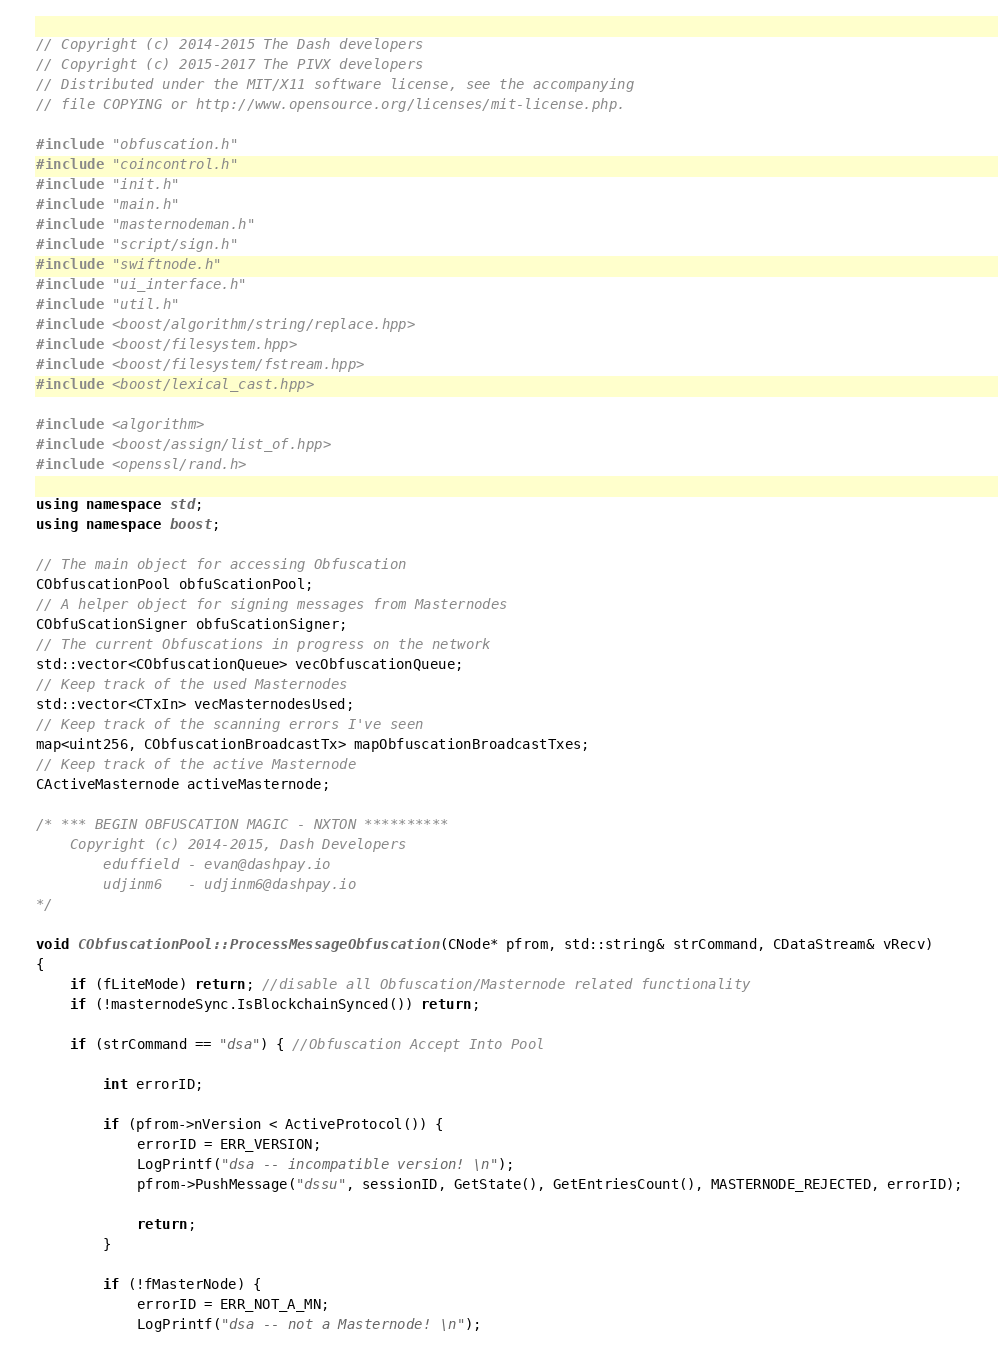Convert code to text. <code><loc_0><loc_0><loc_500><loc_500><_C++_>// Copyright (c) 2014-2015 The Dash developers
// Copyright (c) 2015-2017 The PIVX developers
// Distributed under the MIT/X11 software license, see the accompanying
// file COPYING or http://www.opensource.org/licenses/mit-license.php.

#include "obfuscation.h"
#include "coincontrol.h"
#include "init.h"
#include "main.h"
#include "masternodeman.h"
#include "script/sign.h"
#include "swiftnode.h"
#include "ui_interface.h"
#include "util.h"
#include <boost/algorithm/string/replace.hpp>
#include <boost/filesystem.hpp>
#include <boost/filesystem/fstream.hpp>
#include <boost/lexical_cast.hpp>

#include <algorithm>
#include <boost/assign/list_of.hpp>
#include <openssl/rand.h>

using namespace std;
using namespace boost;

// The main object for accessing Obfuscation
CObfuscationPool obfuScationPool;
// A helper object for signing messages from Masternodes
CObfuScationSigner obfuScationSigner;
// The current Obfuscations in progress on the network
std::vector<CObfuscationQueue> vecObfuscationQueue;
// Keep track of the used Masternodes
std::vector<CTxIn> vecMasternodesUsed;
// Keep track of the scanning errors I've seen
map<uint256, CObfuscationBroadcastTx> mapObfuscationBroadcastTxes;
// Keep track of the active Masternode
CActiveMasternode activeMasternode;

/* *** BEGIN OBFUSCATION MAGIC - NXTON **********
    Copyright (c) 2014-2015, Dash Developers
        eduffield - evan@dashpay.io
        udjinm6   - udjinm6@dashpay.io
*/

void CObfuscationPool::ProcessMessageObfuscation(CNode* pfrom, std::string& strCommand, CDataStream& vRecv)
{
    if (fLiteMode) return; //disable all Obfuscation/Masternode related functionality
    if (!masternodeSync.IsBlockchainSynced()) return;

    if (strCommand == "dsa") { //Obfuscation Accept Into Pool

        int errorID;

        if (pfrom->nVersion < ActiveProtocol()) {
            errorID = ERR_VERSION;
            LogPrintf("dsa -- incompatible version! \n");
            pfrom->PushMessage("dssu", sessionID, GetState(), GetEntriesCount(), MASTERNODE_REJECTED, errorID);

            return;
        }

        if (!fMasterNode) {
            errorID = ERR_NOT_A_MN;
            LogPrintf("dsa -- not a Masternode! \n");</code> 